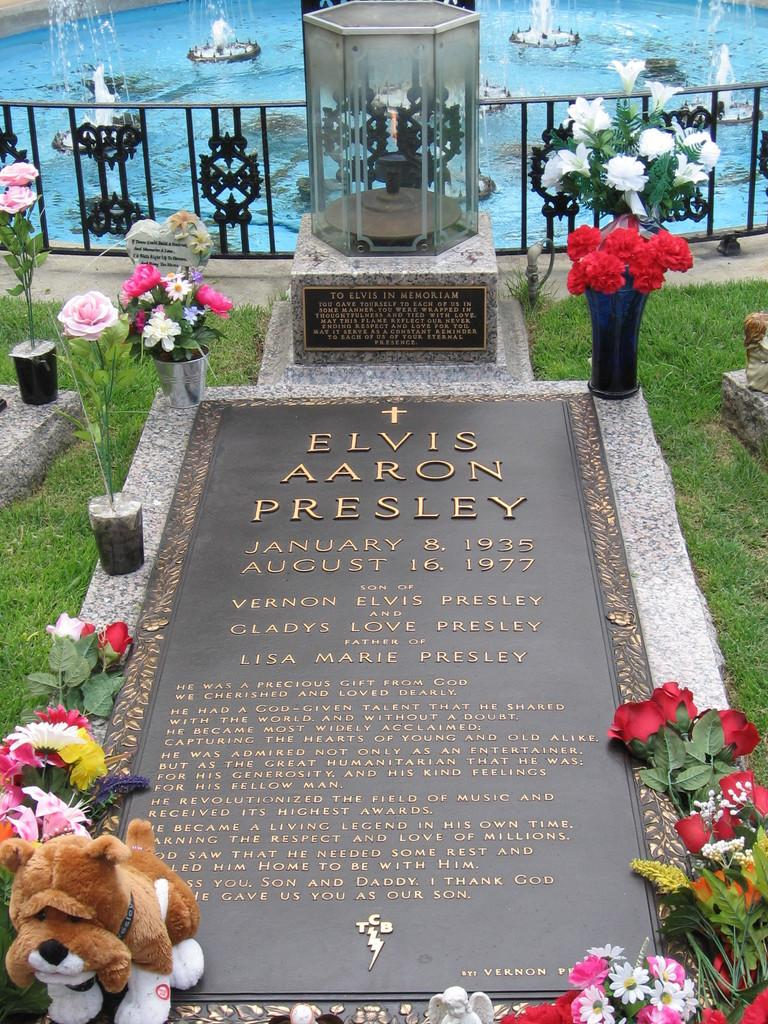What is the main subject of the image? There is a gravestone in the image. Are there any decorations or items placed near the gravestone? Yes, there are flowers and a doll on the gravestone. What else can be seen in the image besides the gravestone? There are flower pots and a fence in the background of the image. What other feature can be seen in the background? There is a fountain in the background of the image. What type of rail system is visible in the image? There is no rail system present in the image. Can you describe the engine that is powering the train in the image? There is no train or engine present in the image. 